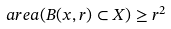Convert formula to latex. <formula><loc_0><loc_0><loc_500><loc_500>\ a r e a ( B ( x , r ) \subset X ) \geq r ^ { 2 }</formula> 